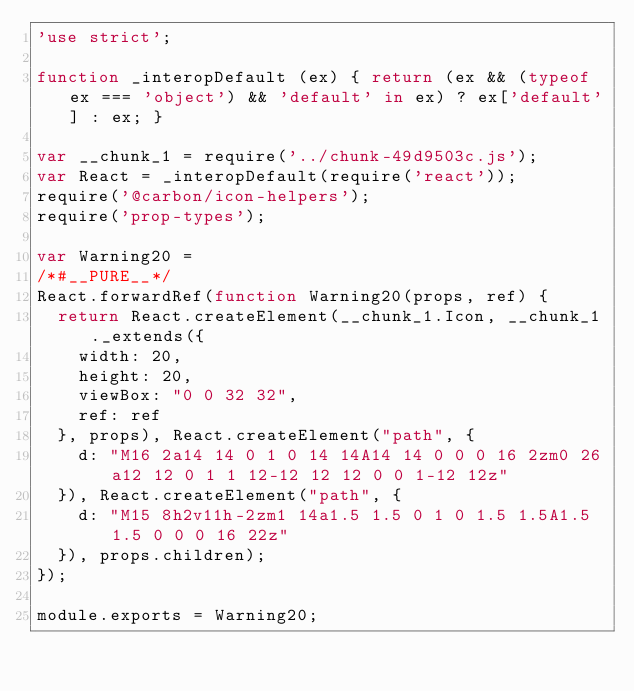Convert code to text. <code><loc_0><loc_0><loc_500><loc_500><_JavaScript_>'use strict';

function _interopDefault (ex) { return (ex && (typeof ex === 'object') && 'default' in ex) ? ex['default'] : ex; }

var __chunk_1 = require('../chunk-49d9503c.js');
var React = _interopDefault(require('react'));
require('@carbon/icon-helpers');
require('prop-types');

var Warning20 =
/*#__PURE__*/
React.forwardRef(function Warning20(props, ref) {
  return React.createElement(__chunk_1.Icon, __chunk_1._extends({
    width: 20,
    height: 20,
    viewBox: "0 0 32 32",
    ref: ref
  }, props), React.createElement("path", {
    d: "M16 2a14 14 0 1 0 14 14A14 14 0 0 0 16 2zm0 26a12 12 0 1 1 12-12 12 12 0 0 1-12 12z"
  }), React.createElement("path", {
    d: "M15 8h2v11h-2zm1 14a1.5 1.5 0 1 0 1.5 1.5A1.5 1.5 0 0 0 16 22z"
  }), props.children);
});

module.exports = Warning20;
</code> 